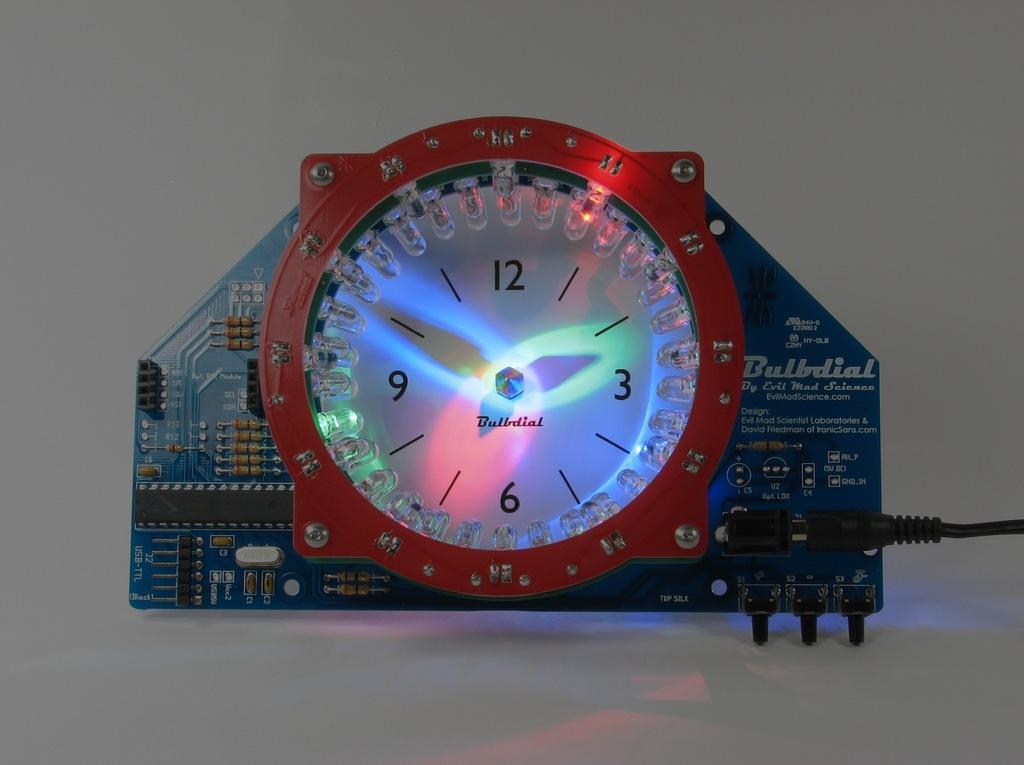What time does the clock read?
Offer a terse response. 2:50. Is thia a bubdial?
Provide a short and direct response. Yes. 